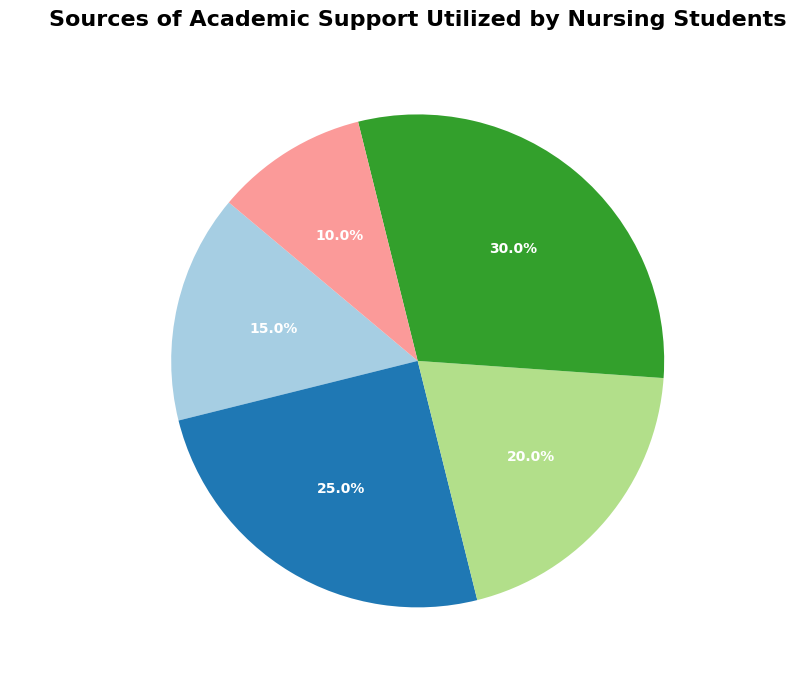What percentage of nursing students utilize faculty office hours? Look at the corresponding slice of the pie chart labeled "Faculty Office Hours." The percentage is provided as "10%."
Answer: 10% Which source of academic support is utilized the most by nursing students? Identify the largest slice of the pie chart. It is labeled "Online Resources," with the highest percentage of 30%.
Answer: Online Resources Calculate the combined percentage of students using tutoring services and academic advising. Find the slices labeled "Tutoring Services" (15%) and "Academic Advising" (20%). Add these percentages: 15% + 20% = 35%.
Answer: 35% What is the difference in the utilization percentage between study groups and faculty office hours? Locate the percentages for "Study Groups" (25%) and "Faculty Office Hours" (10%). Subtract the smaller from the larger: 25% - 10% = 15%.
Answer: 15% Compare the utilization of online resources to academic advising. Is the former greater, and by how much? Check "Online Resources" (30%) and "Academic Advising" (20%). Subtract the two percentages: 30% - 20% = 10%.
Answer: 10% Which support source is represented by the smallest slice of the pie chart? Locate the smallest slice. It corresponds to "Faculty Office Hours" with a percentage of 10%.
Answer: Faculty Office Hours If 200 students were surveyed, how many of them use study groups? The percentage for "Study Groups" is 25%. Calculate 25% of 200: 200 * 0.25 = 50.
Answer: 50 Rank all the sources of academic support from most to least utilized. Order the slices by their percentages: "Online Resources" (30%), "Study Groups" (25%), "Academic Advising" (20%), "Tutoring Services" (15%), "Faculty Office Hours" (10%).
Answer: Online Resources, Study Groups, Academic Advising, Tutoring Services, Faculty Office Hours What is the total percentage of students using either study groups or online resources? Add the percentages for "Study Groups" (25%) and "Online Resources" (30%): 25% + 30% = 55%.
Answer: 55% Determine the average percentage of students utilizing tutoring services, academic advising, and faculty office hours. Sum the percentages: 15% (Tutoring Services) + 20% (Academic Advising) + 10% (Faculty Office Hours) = 45%. Divide by the number of sources: 45% / 3 = 15%.
Answer: 15% 